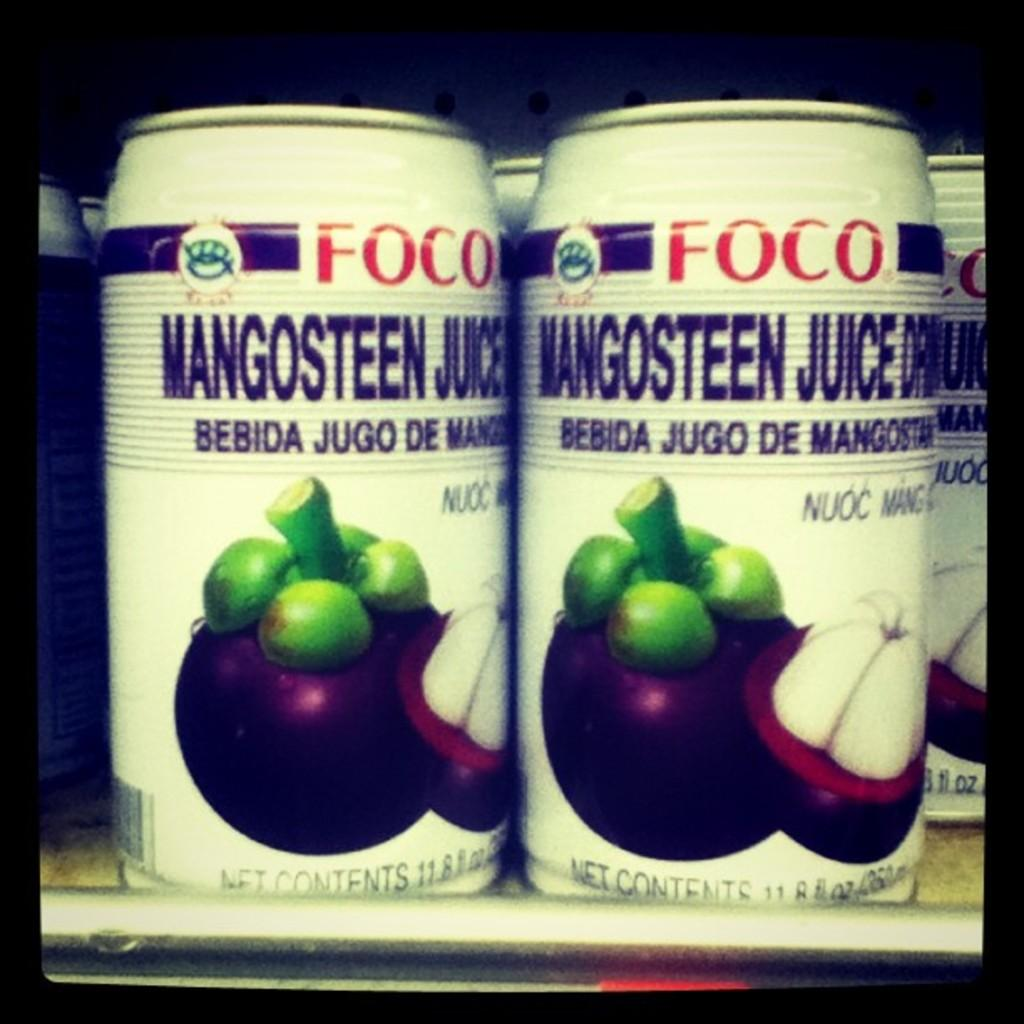What is the main object in the image? There is a food container in the image. What color is the food container? The food container is white. Is there any text or writing on the food container? Yes, there is writing on the food container. Where is the food container located in the image? The food container is in a rack. What type of battle is depicted on the food container? There is no battle depicted on the food container; it only has writing on it. What game is being played on the food container? There is no game being played on the food container; it only has writing on it. 